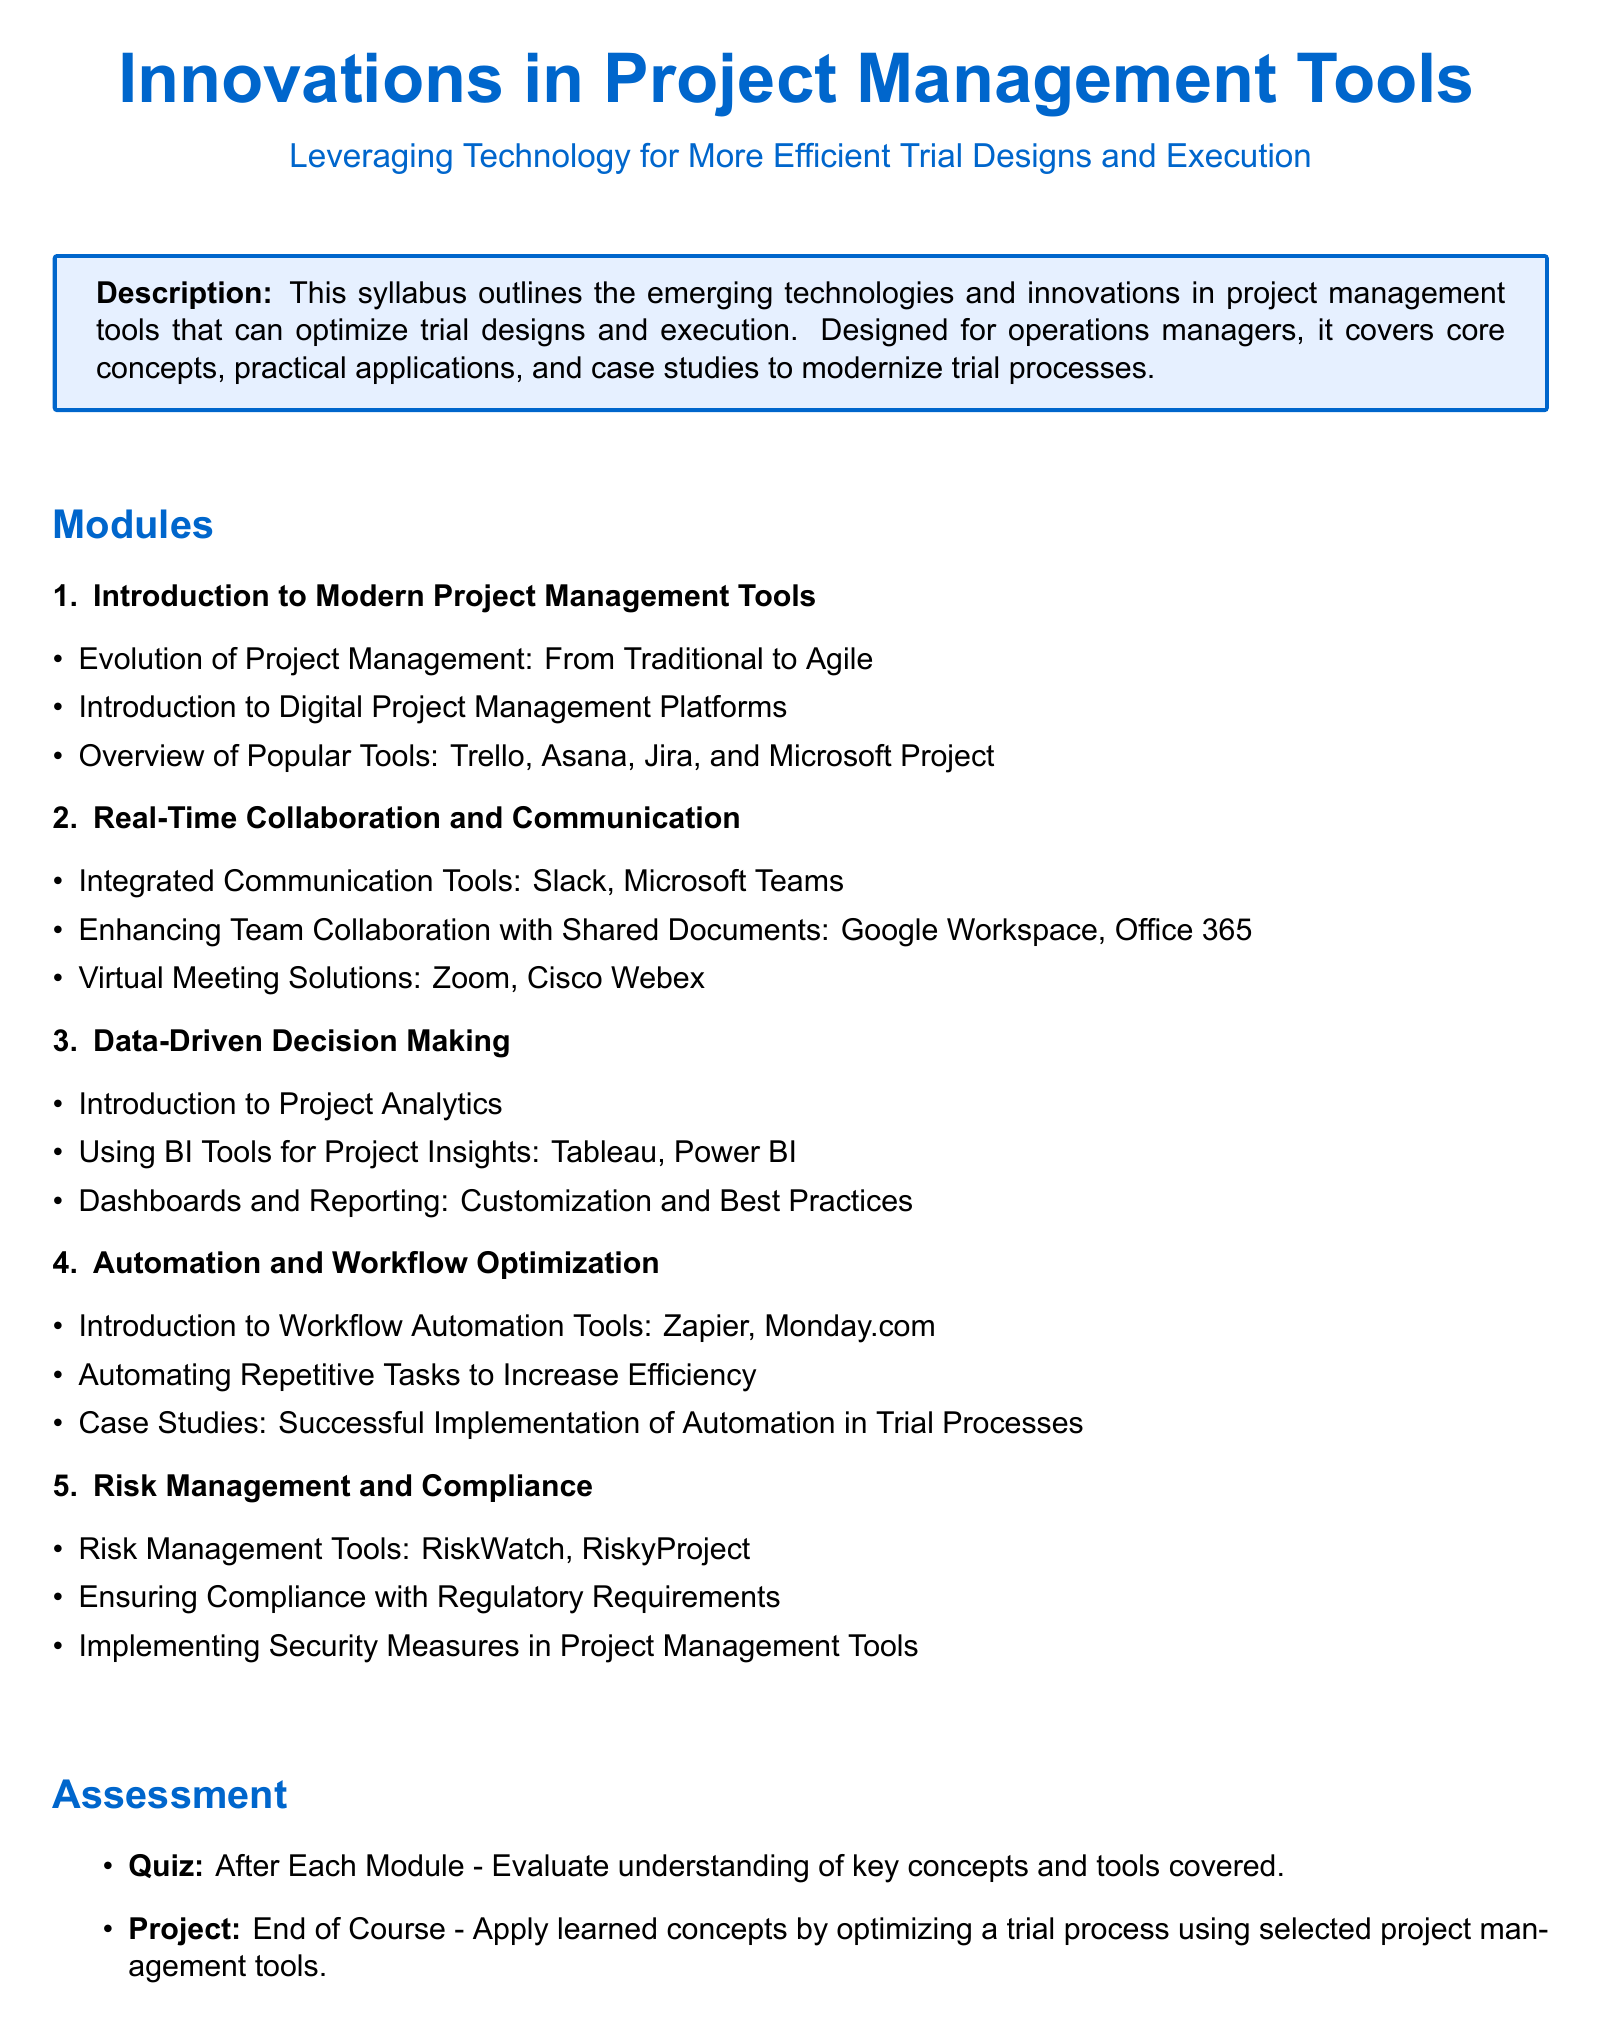What is the primary focus of the syllabus? The syllabus outlines emerging technologies and innovations in project management tools that can optimize trial designs and execution.
Answer: Optimizing trial designs and execution How many modules are included in the syllabus? The syllabus lists a total of five modules covering various aspects of project management tools.
Answer: Five Which tool is mentioned for virtual meeting solutions? The syllabus highlights Cisco Webex as one of the virtual meeting solutions.
Answer: Cisco Webex What type of assessment is conducted after each module? A quiz is used to evaluate understanding of key concepts and tools covered after each module.
Answer: Quiz Name one book recommended in the resources section. The syllabus includes "Project Management 2.0 by Harold Kerzner" as one of the recommended books.
Answer: Project Management 2.0 Which module focuses on integrating communication tools? The second module is dedicated to real-time collaboration and communication, specifically highlighting integrated communication tools.
Answer: Real-Time Collaboration and Communication What is one application mentioned for automating tasks? The syllabus mentions Zapier as a workflow automation tool designed to increase efficiency by automating repetitive tasks.
Answer: Zapier What type of tools does the fourth module discuss? The fourth module discusses workflow automation tools aimed at optimizing trial processes.
Answer: Workflow Automation Tools Who is the syllabus designed for? The syllabus is designed specifically for operations managers overseeing trial processes.
Answer: Operations managers 